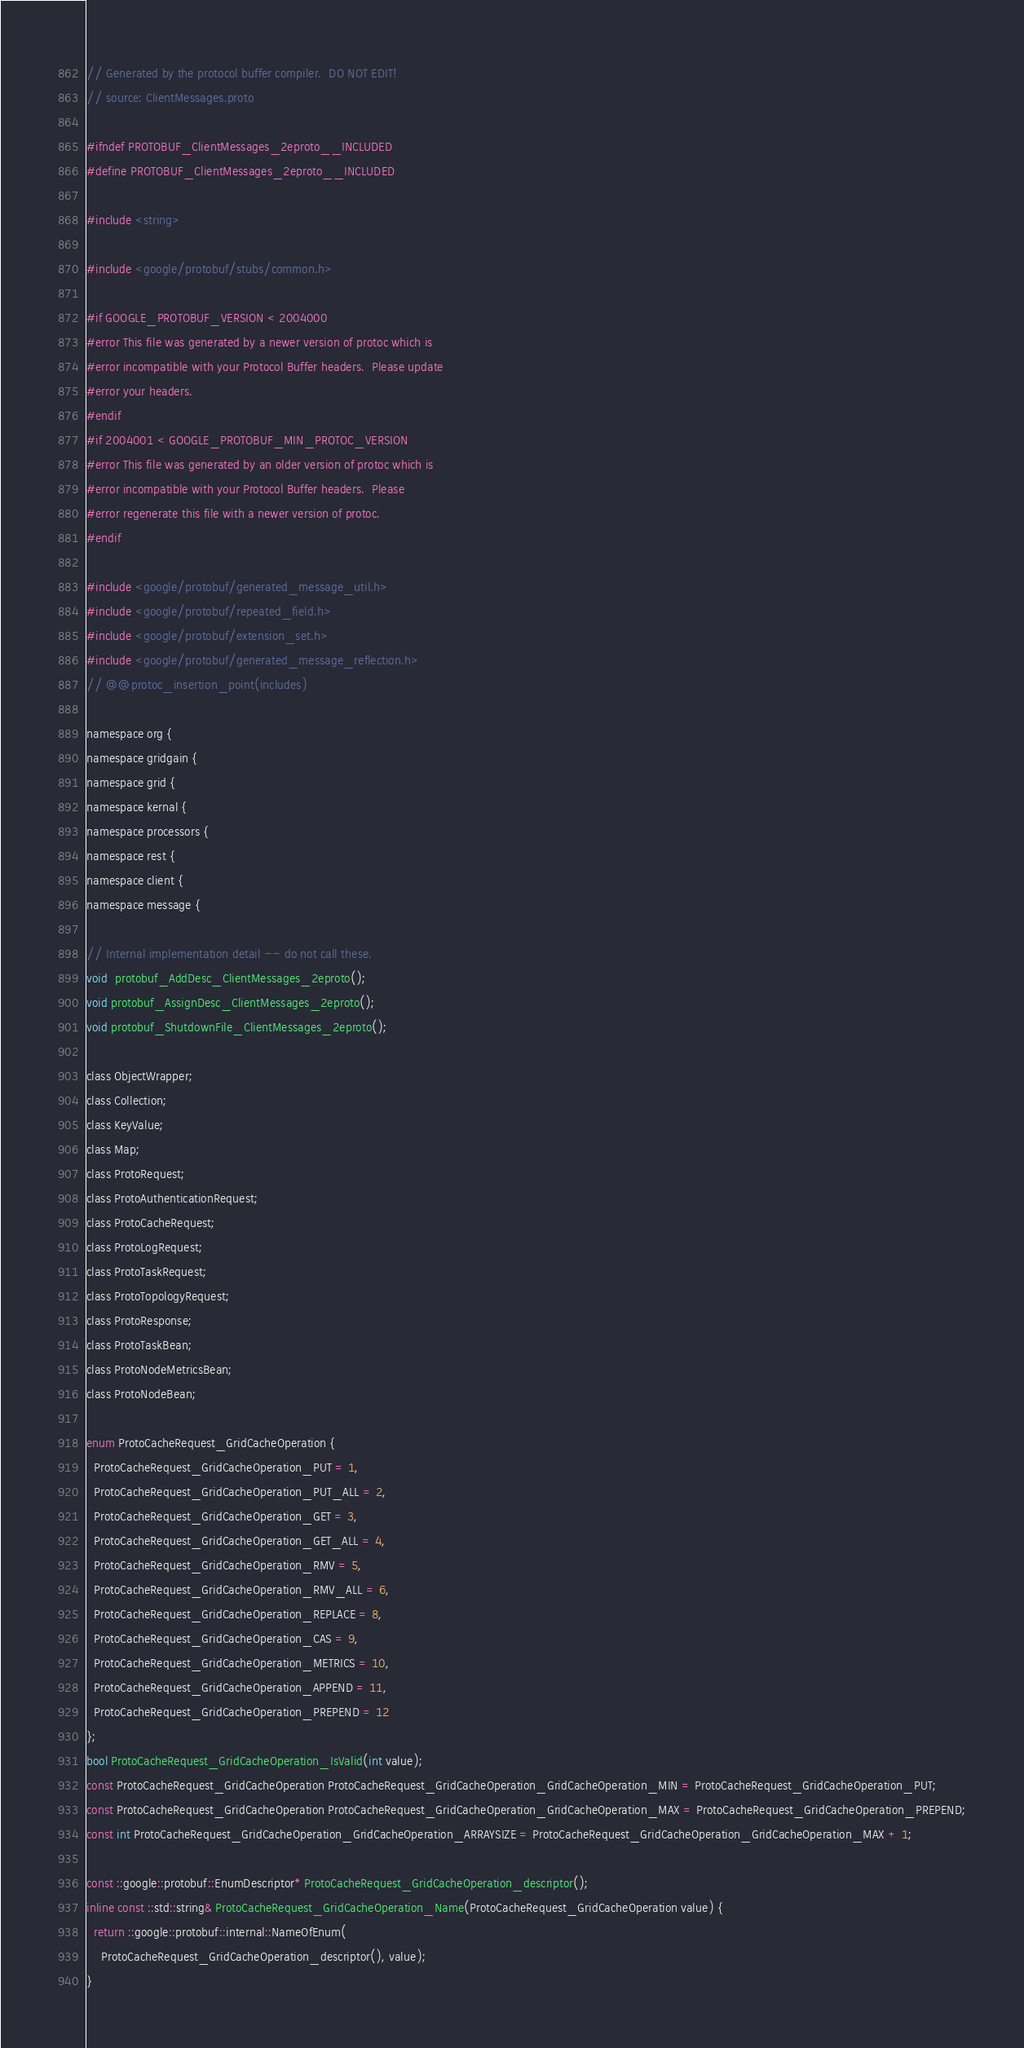Convert code to text. <code><loc_0><loc_0><loc_500><loc_500><_C_>// Generated by the protocol buffer compiler.  DO NOT EDIT!
// source: ClientMessages.proto

#ifndef PROTOBUF_ClientMessages_2eproto__INCLUDED
#define PROTOBUF_ClientMessages_2eproto__INCLUDED

#include <string>

#include <google/protobuf/stubs/common.h>

#if GOOGLE_PROTOBUF_VERSION < 2004000
#error This file was generated by a newer version of protoc which is
#error incompatible with your Protocol Buffer headers.  Please update
#error your headers.
#endif
#if 2004001 < GOOGLE_PROTOBUF_MIN_PROTOC_VERSION
#error This file was generated by an older version of protoc which is
#error incompatible with your Protocol Buffer headers.  Please
#error regenerate this file with a newer version of protoc.
#endif

#include <google/protobuf/generated_message_util.h>
#include <google/protobuf/repeated_field.h>
#include <google/protobuf/extension_set.h>
#include <google/protobuf/generated_message_reflection.h>
// @@protoc_insertion_point(includes)

namespace org {
namespace gridgain {
namespace grid {
namespace kernal {
namespace processors {
namespace rest {
namespace client {
namespace message {

// Internal implementation detail -- do not call these.
void  protobuf_AddDesc_ClientMessages_2eproto();
void protobuf_AssignDesc_ClientMessages_2eproto();
void protobuf_ShutdownFile_ClientMessages_2eproto();

class ObjectWrapper;
class Collection;
class KeyValue;
class Map;
class ProtoRequest;
class ProtoAuthenticationRequest;
class ProtoCacheRequest;
class ProtoLogRequest;
class ProtoTaskRequest;
class ProtoTopologyRequest;
class ProtoResponse;
class ProtoTaskBean;
class ProtoNodeMetricsBean;
class ProtoNodeBean;

enum ProtoCacheRequest_GridCacheOperation {
  ProtoCacheRequest_GridCacheOperation_PUT = 1,
  ProtoCacheRequest_GridCacheOperation_PUT_ALL = 2,
  ProtoCacheRequest_GridCacheOperation_GET = 3,
  ProtoCacheRequest_GridCacheOperation_GET_ALL = 4,
  ProtoCacheRequest_GridCacheOperation_RMV = 5,
  ProtoCacheRequest_GridCacheOperation_RMV_ALL = 6,
  ProtoCacheRequest_GridCacheOperation_REPLACE = 8,
  ProtoCacheRequest_GridCacheOperation_CAS = 9,
  ProtoCacheRequest_GridCacheOperation_METRICS = 10,
  ProtoCacheRequest_GridCacheOperation_APPEND = 11,
  ProtoCacheRequest_GridCacheOperation_PREPEND = 12
};
bool ProtoCacheRequest_GridCacheOperation_IsValid(int value);
const ProtoCacheRequest_GridCacheOperation ProtoCacheRequest_GridCacheOperation_GridCacheOperation_MIN = ProtoCacheRequest_GridCacheOperation_PUT;
const ProtoCacheRequest_GridCacheOperation ProtoCacheRequest_GridCacheOperation_GridCacheOperation_MAX = ProtoCacheRequest_GridCacheOperation_PREPEND;
const int ProtoCacheRequest_GridCacheOperation_GridCacheOperation_ARRAYSIZE = ProtoCacheRequest_GridCacheOperation_GridCacheOperation_MAX + 1;

const ::google::protobuf::EnumDescriptor* ProtoCacheRequest_GridCacheOperation_descriptor();
inline const ::std::string& ProtoCacheRequest_GridCacheOperation_Name(ProtoCacheRequest_GridCacheOperation value) {
  return ::google::protobuf::internal::NameOfEnum(
    ProtoCacheRequest_GridCacheOperation_descriptor(), value);
}</code> 